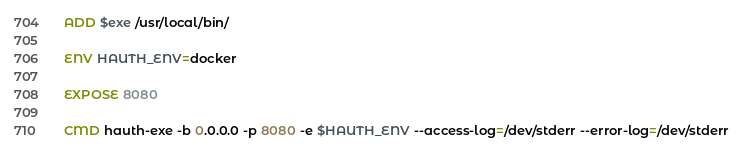<code> <loc_0><loc_0><loc_500><loc_500><_Dockerfile_>ADD $exe /usr/local/bin/

ENV HAUTH_ENV=docker

EXPOSE 8080

CMD hauth-exe -b 0.0.0.0 -p 8080 -e $HAUTH_ENV --access-log=/dev/stderr --error-log=/dev/stderr
</code> 